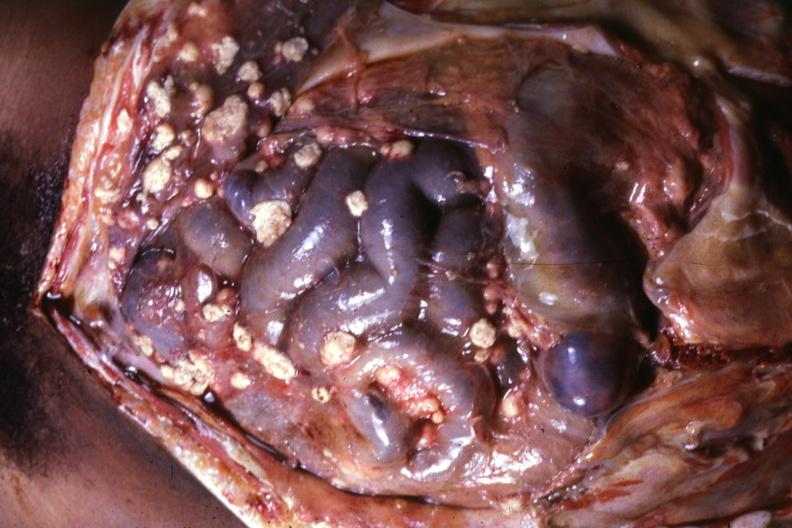where is this area in the body?
Answer the question using a single word or phrase. Abdomen 